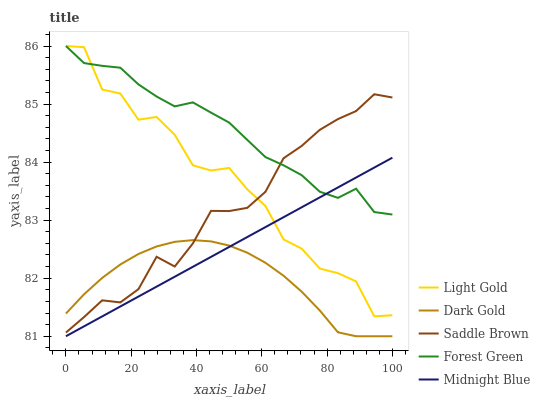Does Midnight Blue have the minimum area under the curve?
Answer yes or no. No. Does Midnight Blue have the maximum area under the curve?
Answer yes or no. No. Is Light Gold the smoothest?
Answer yes or no. No. Is Midnight Blue the roughest?
Answer yes or no. No. Does Light Gold have the lowest value?
Answer yes or no. No. Does Midnight Blue have the highest value?
Answer yes or no. No. Is Dark Gold less than Forest Green?
Answer yes or no. Yes. Is Saddle Brown greater than Midnight Blue?
Answer yes or no. Yes. Does Dark Gold intersect Forest Green?
Answer yes or no. No. 